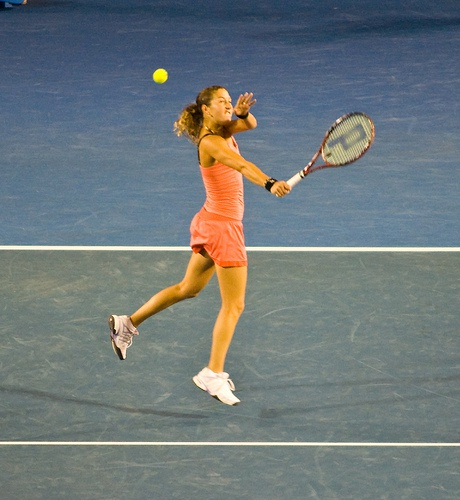Describe the objects in this image and their specific colors. I can see people in darkblue, orange, red, and olive tones, tennis racket in darkblue, tan, and gray tones, and sports ball in darkblue, yellow, khaki, olive, and gray tones in this image. 